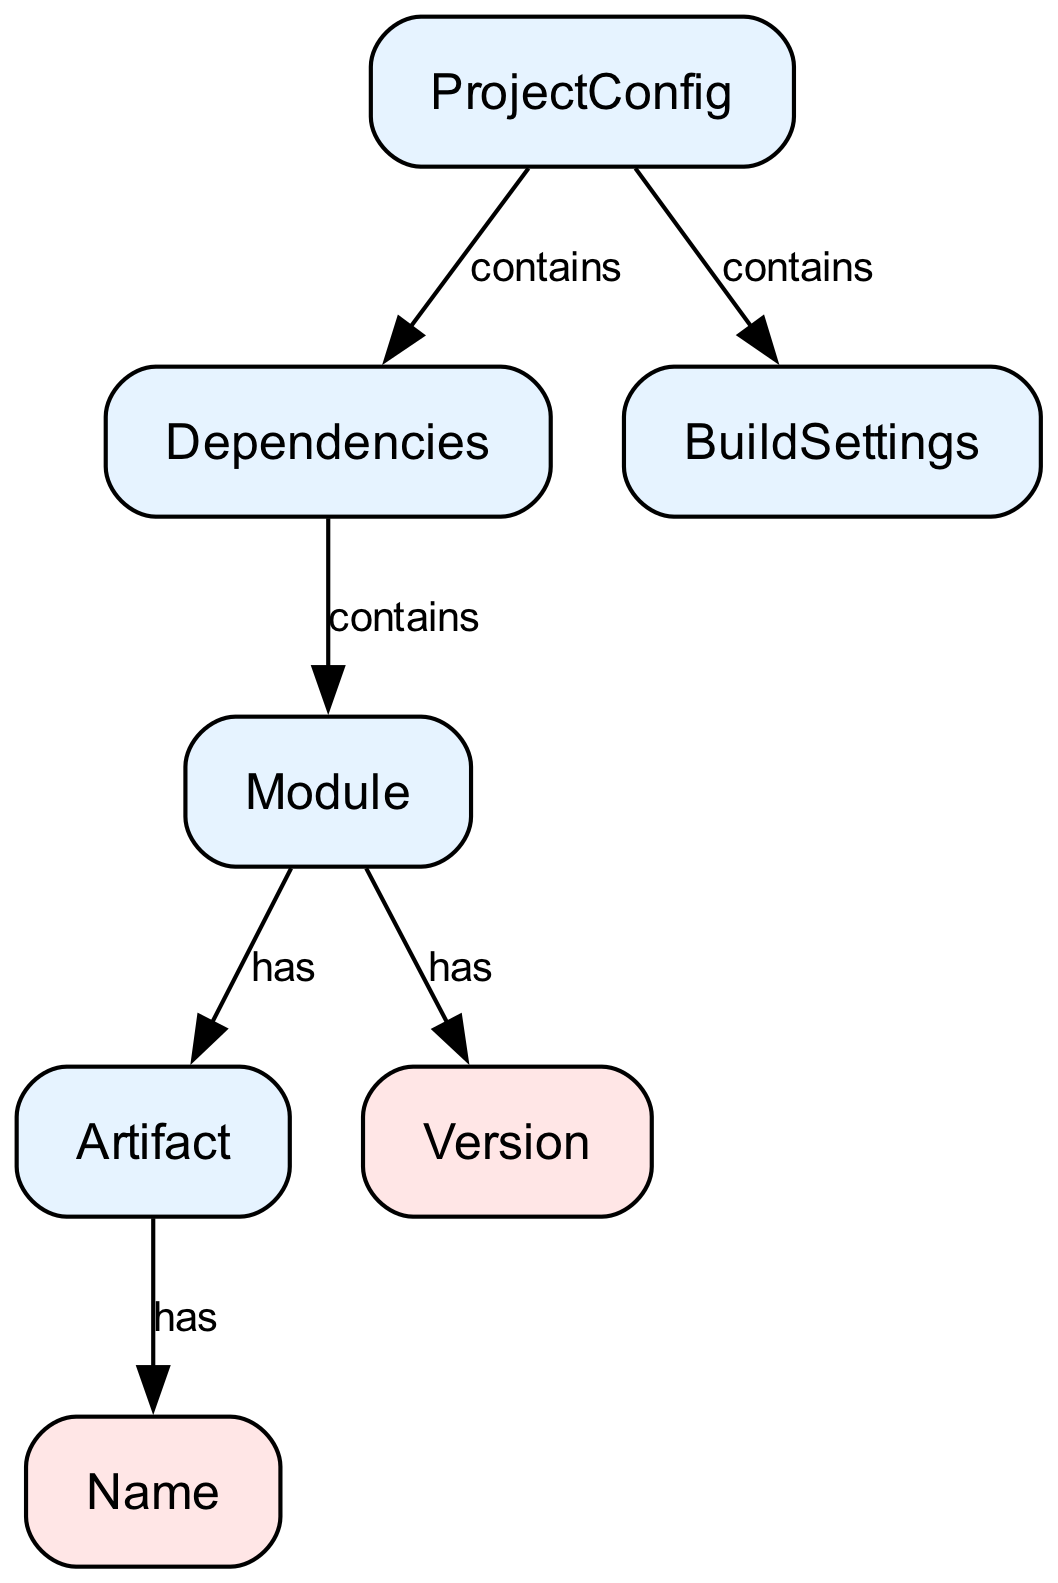What is the root node of the diagram? The root node is labeled as "ProjectConfig," which represents the main configuration for the project. This is identified directly from the diagram's layout, where the node at the top (root) represents the central configuration point.
Answer: ProjectConfig How many complex types are present in the diagram? By reviewing the nodes listed in the diagram, four nodes are categorized as complex types: "ProjectConfig," "Dependencies," "BuildSettings," and "Module." Thus, counting these nodes gives the answer.
Answer: 4 What is the relationship between "Module" and "Artifact"? The "Module" contains "Artifact," as indicated by the edge labeled "has" connecting these two nodes. This can be observed directly from the edge description in the diagram.
Answer: has Which node has the attribute named "name"? The "Artifact" node has the attribute "name," indicated by the edge connecting "Artifact" to "Name" with the label "has." It can be confirmed by following the directional flow from "Artifact" to its attributes.
Answer: Artifact What type of structure does "ProjectConfig" encompass? The "ProjectConfig" encompasses complex types, specifically "Dependencies" and "BuildSettings," as these are connected with edges labeled "contains." This direct connection illustrates what elements are part of the "ProjectConfig" structure.
Answer: complex types How many edges are present between "Dependencies" and the "Module"? There is one edge that goes from "Dependencies" to "Module," labeled "contains." This can be confirmed by counting the edges originating from "Dependencies."
Answer: 1 Which element is nested under "Module"? The elements "Artifact" and "Version" are nested under "Module," both of which are connected to "Module" with edges labeled "has." By examining the connections leading from "Module," both elements can be identified.
Answer: Artifact, Version What is indicated by the edge connecting "artifact" and "name"? The edge indicates that "Artifact" has an attribute named "name." This relationship is shown directly in the diagram where "Artifact" points to "name."
Answer: has What is the first node connected to the root in the diagram? The first connected node under "ProjectConfig" is "Dependencies," as indicated by the direction of the edge that originates at the root. This can be seen as the first branch from the main configuration node.
Answer: Dependencies 